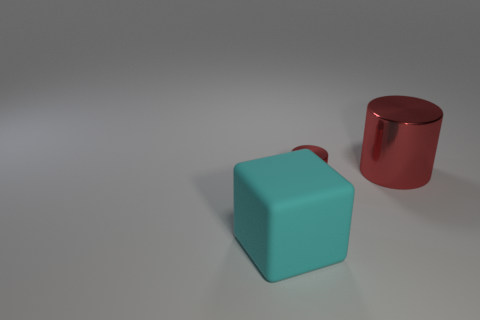Add 3 red things. How many objects exist? 6 Subtract all cubes. How many objects are left? 2 Subtract all large red shiny objects. Subtract all blue metal cubes. How many objects are left? 2 Add 1 large red cylinders. How many large red cylinders are left? 2 Add 2 big cubes. How many big cubes exist? 3 Subtract 0 yellow spheres. How many objects are left? 3 Subtract 1 cubes. How many cubes are left? 0 Subtract all purple cylinders. Subtract all yellow cubes. How many cylinders are left? 2 